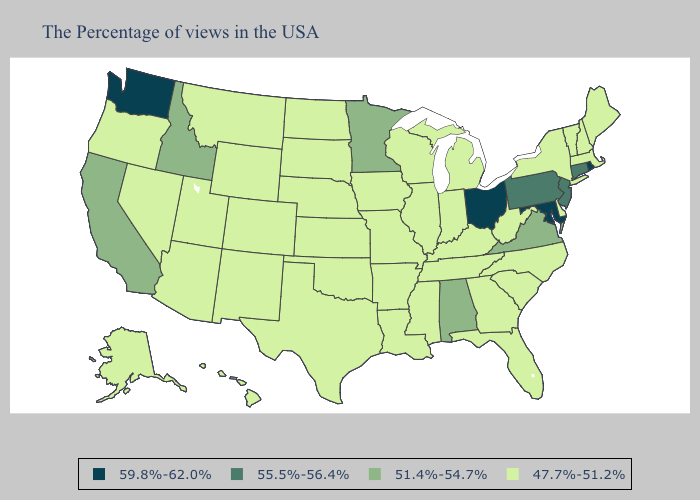Does North Carolina have the highest value in the South?
Short answer required. No. Does Massachusetts have the highest value in the Northeast?
Keep it brief. No. Does Kentucky have the same value as Washington?
Short answer required. No. What is the value of Maine?
Write a very short answer. 47.7%-51.2%. Among the states that border Ohio , which have the lowest value?
Answer briefly. West Virginia, Michigan, Kentucky, Indiana. Does New Mexico have a higher value than Maine?
Give a very brief answer. No. What is the lowest value in states that border Arizona?
Concise answer only. 47.7%-51.2%. Which states have the lowest value in the USA?
Write a very short answer. Maine, Massachusetts, New Hampshire, Vermont, New York, Delaware, North Carolina, South Carolina, West Virginia, Florida, Georgia, Michigan, Kentucky, Indiana, Tennessee, Wisconsin, Illinois, Mississippi, Louisiana, Missouri, Arkansas, Iowa, Kansas, Nebraska, Oklahoma, Texas, South Dakota, North Dakota, Wyoming, Colorado, New Mexico, Utah, Montana, Arizona, Nevada, Oregon, Alaska, Hawaii. What is the value of Pennsylvania?
Be succinct. 55.5%-56.4%. Which states have the lowest value in the USA?
Answer briefly. Maine, Massachusetts, New Hampshire, Vermont, New York, Delaware, North Carolina, South Carolina, West Virginia, Florida, Georgia, Michigan, Kentucky, Indiana, Tennessee, Wisconsin, Illinois, Mississippi, Louisiana, Missouri, Arkansas, Iowa, Kansas, Nebraska, Oklahoma, Texas, South Dakota, North Dakota, Wyoming, Colorado, New Mexico, Utah, Montana, Arizona, Nevada, Oregon, Alaska, Hawaii. What is the lowest value in the Northeast?
Concise answer only. 47.7%-51.2%. What is the value of Colorado?
Be succinct. 47.7%-51.2%. What is the highest value in the USA?
Be succinct. 59.8%-62.0%. Which states hav the highest value in the Northeast?
Keep it brief. Rhode Island. Name the states that have a value in the range 59.8%-62.0%?
Short answer required. Rhode Island, Maryland, Ohio, Washington. 